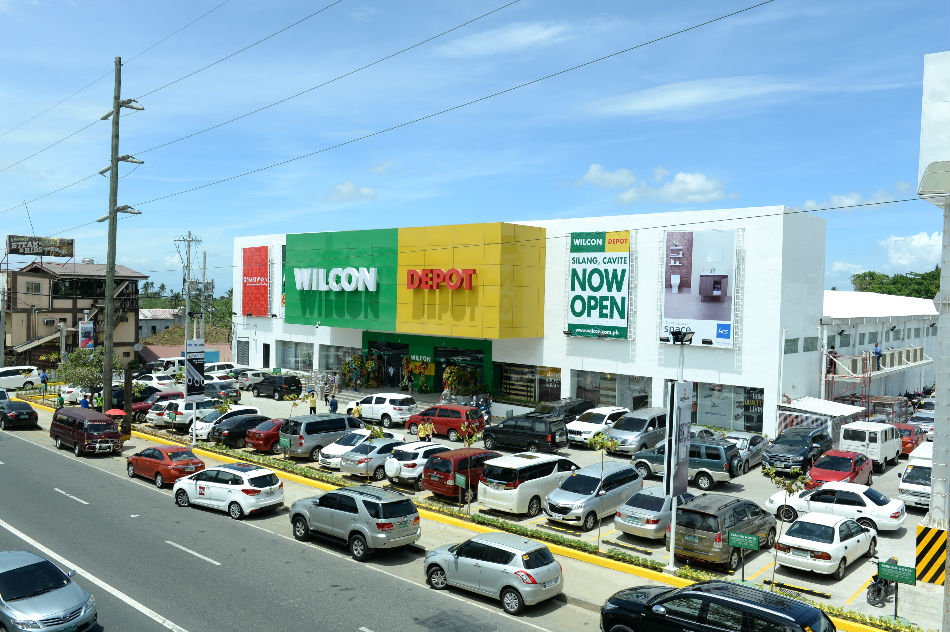From observing the types of vehicles and the architecture, what can we deduce about the socio-economic status of the area? Be as detailed as possible. The variety of vehicles, including both economy and mid-range models, indicates a diverse socio-economic demographic. The architecture of the commercial building is modern and well-maintained, suggesting that the developers have invested significantly in creating an appealing shopping environment. The presence of both cars and SUVs hints at a middle to upper-middle-class clientele who can afford personal vehicles and regular shopping excursions. The clean streets and organized parking further underscore a relatively affluent and developed area, focused on providing a pleasant consumer experience. 